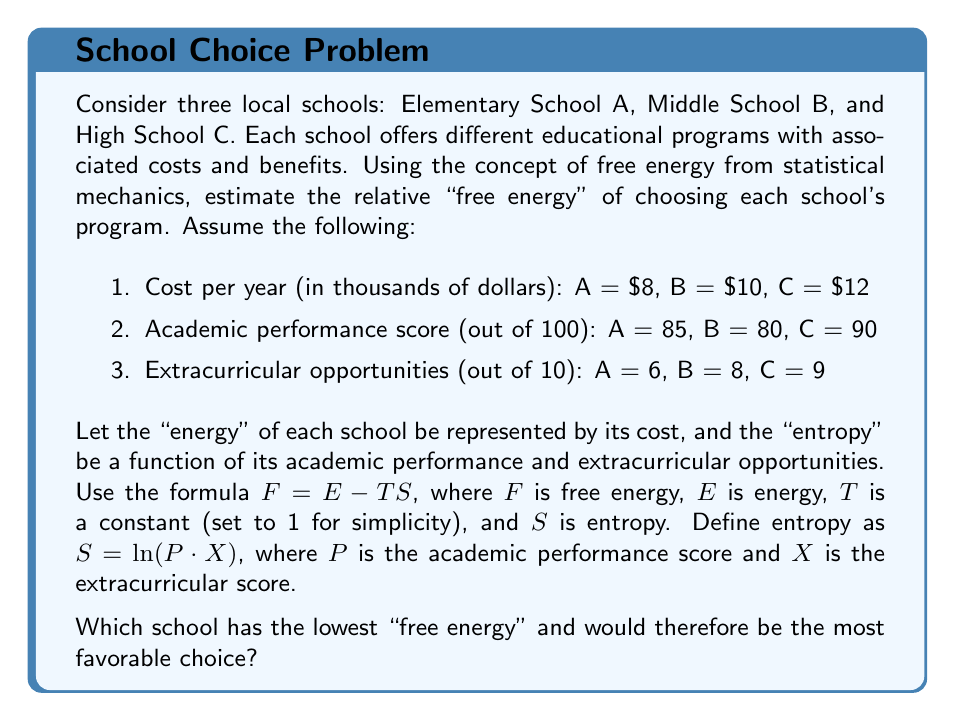Can you answer this question? To solve this problem, we'll calculate the free energy for each school using the given formula and data:

1. Calculate entropy $S$ for each school:
   $S = \ln(P \cdot X)$

   School A: $S_A = \ln(85 \cdot 6) = \ln(510) \approx 6.234$
   School B: $S_B = \ln(80 \cdot 8) = \ln(640) \approx 6.461$
   School C: $S_C = \ln(90 \cdot 9) = \ln(810) \approx 6.697$

2. Calculate free energy $F$ for each school:
   $F = E - TS$, where $T = 1$

   School A: $F_A = 8 - (1 \cdot 6.234) = 1.766$
   School B: $F_B = 10 - (1 \cdot 6.461) = 3.539$
   School C: $F_C = 12 - (1 \cdot 6.697) = 5.303$

3. Compare the free energies:
   $F_A < F_B < F_C$

Therefore, School A has the lowest free energy and would be the most favorable choice according to this model.
Answer: School A (Elementary School) 